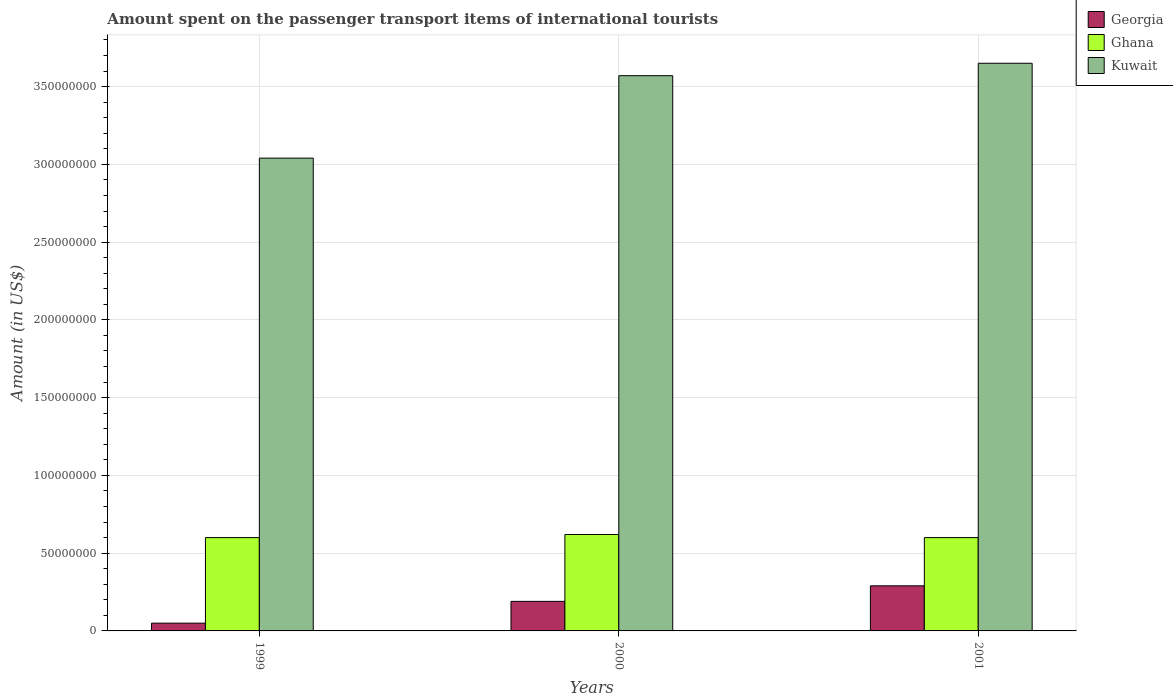How many different coloured bars are there?
Offer a terse response. 3. Are the number of bars on each tick of the X-axis equal?
Your answer should be very brief. Yes. In how many cases, is the number of bars for a given year not equal to the number of legend labels?
Ensure brevity in your answer.  0. What is the amount spent on the passenger transport items of international tourists in Kuwait in 1999?
Your answer should be very brief. 3.04e+08. Across all years, what is the maximum amount spent on the passenger transport items of international tourists in Kuwait?
Provide a short and direct response. 3.65e+08. Across all years, what is the minimum amount spent on the passenger transport items of international tourists in Kuwait?
Offer a terse response. 3.04e+08. In which year was the amount spent on the passenger transport items of international tourists in Georgia maximum?
Your response must be concise. 2001. What is the total amount spent on the passenger transport items of international tourists in Ghana in the graph?
Provide a short and direct response. 1.82e+08. What is the difference between the amount spent on the passenger transport items of international tourists in Ghana in 1999 and that in 2000?
Provide a short and direct response. -2.00e+06. What is the difference between the amount spent on the passenger transport items of international tourists in Georgia in 2000 and the amount spent on the passenger transport items of international tourists in Ghana in 1999?
Your response must be concise. -4.10e+07. What is the average amount spent on the passenger transport items of international tourists in Ghana per year?
Offer a terse response. 6.07e+07. In the year 1999, what is the difference between the amount spent on the passenger transport items of international tourists in Kuwait and amount spent on the passenger transport items of international tourists in Ghana?
Your answer should be compact. 2.44e+08. In how many years, is the amount spent on the passenger transport items of international tourists in Georgia greater than 360000000 US$?
Ensure brevity in your answer.  0. What is the ratio of the amount spent on the passenger transport items of international tourists in Ghana in 2000 to that in 2001?
Provide a short and direct response. 1.03. What is the difference between the highest and the second highest amount spent on the passenger transport items of international tourists in Ghana?
Make the answer very short. 2.00e+06. What is the difference between the highest and the lowest amount spent on the passenger transport items of international tourists in Kuwait?
Offer a terse response. 6.10e+07. In how many years, is the amount spent on the passenger transport items of international tourists in Ghana greater than the average amount spent on the passenger transport items of international tourists in Ghana taken over all years?
Offer a terse response. 1. What does the 2nd bar from the left in 1999 represents?
Offer a terse response. Ghana. What does the 3rd bar from the right in 1999 represents?
Offer a very short reply. Georgia. Is it the case that in every year, the sum of the amount spent on the passenger transport items of international tourists in Kuwait and amount spent on the passenger transport items of international tourists in Ghana is greater than the amount spent on the passenger transport items of international tourists in Georgia?
Provide a short and direct response. Yes. How many years are there in the graph?
Offer a terse response. 3. What is the difference between two consecutive major ticks on the Y-axis?
Offer a very short reply. 5.00e+07. Does the graph contain any zero values?
Give a very brief answer. No. What is the title of the graph?
Your answer should be compact. Amount spent on the passenger transport items of international tourists. What is the Amount (in US$) in Georgia in 1999?
Provide a short and direct response. 5.00e+06. What is the Amount (in US$) in Ghana in 1999?
Provide a succinct answer. 6.00e+07. What is the Amount (in US$) of Kuwait in 1999?
Offer a terse response. 3.04e+08. What is the Amount (in US$) of Georgia in 2000?
Give a very brief answer. 1.90e+07. What is the Amount (in US$) in Ghana in 2000?
Your answer should be compact. 6.20e+07. What is the Amount (in US$) of Kuwait in 2000?
Ensure brevity in your answer.  3.57e+08. What is the Amount (in US$) in Georgia in 2001?
Offer a terse response. 2.90e+07. What is the Amount (in US$) of Ghana in 2001?
Your answer should be compact. 6.00e+07. What is the Amount (in US$) of Kuwait in 2001?
Ensure brevity in your answer.  3.65e+08. Across all years, what is the maximum Amount (in US$) in Georgia?
Make the answer very short. 2.90e+07. Across all years, what is the maximum Amount (in US$) of Ghana?
Give a very brief answer. 6.20e+07. Across all years, what is the maximum Amount (in US$) of Kuwait?
Make the answer very short. 3.65e+08. Across all years, what is the minimum Amount (in US$) in Ghana?
Your answer should be compact. 6.00e+07. Across all years, what is the minimum Amount (in US$) in Kuwait?
Offer a terse response. 3.04e+08. What is the total Amount (in US$) of Georgia in the graph?
Provide a succinct answer. 5.30e+07. What is the total Amount (in US$) in Ghana in the graph?
Offer a very short reply. 1.82e+08. What is the total Amount (in US$) in Kuwait in the graph?
Offer a very short reply. 1.03e+09. What is the difference between the Amount (in US$) of Georgia in 1999 and that in 2000?
Give a very brief answer. -1.40e+07. What is the difference between the Amount (in US$) in Ghana in 1999 and that in 2000?
Your answer should be compact. -2.00e+06. What is the difference between the Amount (in US$) of Kuwait in 1999 and that in 2000?
Offer a terse response. -5.30e+07. What is the difference between the Amount (in US$) of Georgia in 1999 and that in 2001?
Ensure brevity in your answer.  -2.40e+07. What is the difference between the Amount (in US$) of Kuwait in 1999 and that in 2001?
Give a very brief answer. -6.10e+07. What is the difference between the Amount (in US$) in Georgia in 2000 and that in 2001?
Make the answer very short. -1.00e+07. What is the difference between the Amount (in US$) in Kuwait in 2000 and that in 2001?
Offer a very short reply. -8.00e+06. What is the difference between the Amount (in US$) in Georgia in 1999 and the Amount (in US$) in Ghana in 2000?
Give a very brief answer. -5.70e+07. What is the difference between the Amount (in US$) of Georgia in 1999 and the Amount (in US$) of Kuwait in 2000?
Your answer should be very brief. -3.52e+08. What is the difference between the Amount (in US$) of Ghana in 1999 and the Amount (in US$) of Kuwait in 2000?
Your answer should be compact. -2.97e+08. What is the difference between the Amount (in US$) in Georgia in 1999 and the Amount (in US$) in Ghana in 2001?
Provide a succinct answer. -5.50e+07. What is the difference between the Amount (in US$) in Georgia in 1999 and the Amount (in US$) in Kuwait in 2001?
Offer a terse response. -3.60e+08. What is the difference between the Amount (in US$) of Ghana in 1999 and the Amount (in US$) of Kuwait in 2001?
Your answer should be very brief. -3.05e+08. What is the difference between the Amount (in US$) of Georgia in 2000 and the Amount (in US$) of Ghana in 2001?
Offer a very short reply. -4.10e+07. What is the difference between the Amount (in US$) of Georgia in 2000 and the Amount (in US$) of Kuwait in 2001?
Your answer should be compact. -3.46e+08. What is the difference between the Amount (in US$) of Ghana in 2000 and the Amount (in US$) of Kuwait in 2001?
Your answer should be compact. -3.03e+08. What is the average Amount (in US$) of Georgia per year?
Provide a succinct answer. 1.77e+07. What is the average Amount (in US$) in Ghana per year?
Provide a succinct answer. 6.07e+07. What is the average Amount (in US$) of Kuwait per year?
Provide a short and direct response. 3.42e+08. In the year 1999, what is the difference between the Amount (in US$) of Georgia and Amount (in US$) of Ghana?
Provide a short and direct response. -5.50e+07. In the year 1999, what is the difference between the Amount (in US$) in Georgia and Amount (in US$) in Kuwait?
Ensure brevity in your answer.  -2.99e+08. In the year 1999, what is the difference between the Amount (in US$) in Ghana and Amount (in US$) in Kuwait?
Offer a very short reply. -2.44e+08. In the year 2000, what is the difference between the Amount (in US$) in Georgia and Amount (in US$) in Ghana?
Ensure brevity in your answer.  -4.30e+07. In the year 2000, what is the difference between the Amount (in US$) of Georgia and Amount (in US$) of Kuwait?
Your answer should be compact. -3.38e+08. In the year 2000, what is the difference between the Amount (in US$) of Ghana and Amount (in US$) of Kuwait?
Offer a terse response. -2.95e+08. In the year 2001, what is the difference between the Amount (in US$) in Georgia and Amount (in US$) in Ghana?
Make the answer very short. -3.10e+07. In the year 2001, what is the difference between the Amount (in US$) in Georgia and Amount (in US$) in Kuwait?
Offer a very short reply. -3.36e+08. In the year 2001, what is the difference between the Amount (in US$) in Ghana and Amount (in US$) in Kuwait?
Ensure brevity in your answer.  -3.05e+08. What is the ratio of the Amount (in US$) in Georgia in 1999 to that in 2000?
Keep it short and to the point. 0.26. What is the ratio of the Amount (in US$) in Kuwait in 1999 to that in 2000?
Provide a short and direct response. 0.85. What is the ratio of the Amount (in US$) of Georgia in 1999 to that in 2001?
Offer a terse response. 0.17. What is the ratio of the Amount (in US$) of Ghana in 1999 to that in 2001?
Your answer should be very brief. 1. What is the ratio of the Amount (in US$) in Kuwait in 1999 to that in 2001?
Your response must be concise. 0.83. What is the ratio of the Amount (in US$) of Georgia in 2000 to that in 2001?
Provide a succinct answer. 0.66. What is the ratio of the Amount (in US$) in Ghana in 2000 to that in 2001?
Your response must be concise. 1.03. What is the ratio of the Amount (in US$) in Kuwait in 2000 to that in 2001?
Your response must be concise. 0.98. What is the difference between the highest and the second highest Amount (in US$) of Georgia?
Your response must be concise. 1.00e+07. What is the difference between the highest and the second highest Amount (in US$) in Kuwait?
Offer a very short reply. 8.00e+06. What is the difference between the highest and the lowest Amount (in US$) of Georgia?
Give a very brief answer. 2.40e+07. What is the difference between the highest and the lowest Amount (in US$) in Kuwait?
Offer a very short reply. 6.10e+07. 